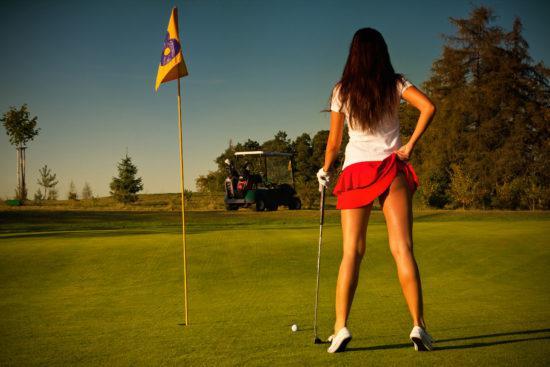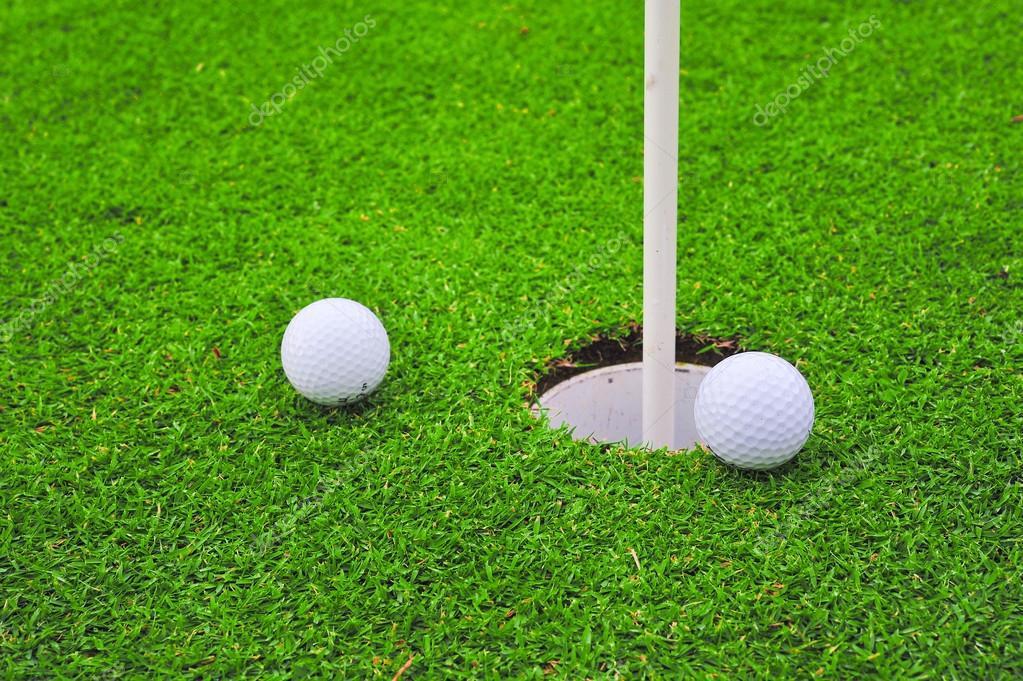The first image is the image on the left, the second image is the image on the right. Evaluate the accuracy of this statement regarding the images: "There are three golf balls, one on the left and two on the right, and no people.". Is it true? Answer yes or no. No. The first image is the image on the left, the second image is the image on the right. Evaluate the accuracy of this statement regarding the images: "At least one golf ball is within about six inches of a hole with a pole sticking out of it.". Is it true? Answer yes or no. Yes. 